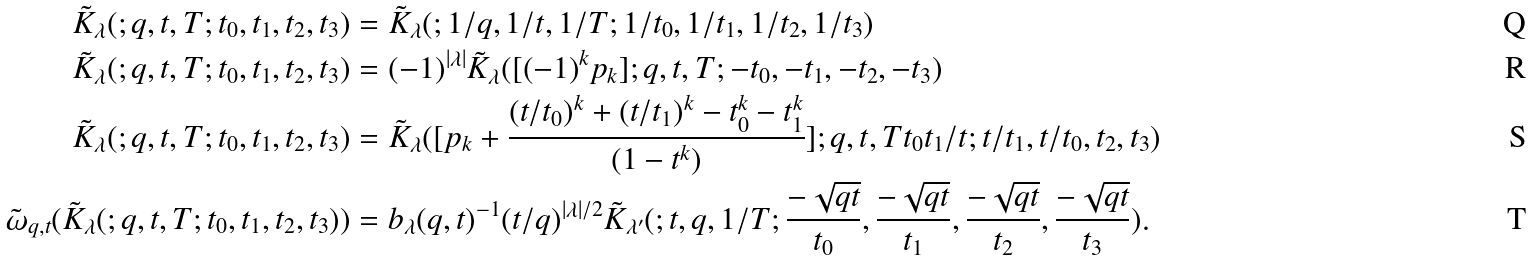<formula> <loc_0><loc_0><loc_500><loc_500>\tilde { K } _ { \lambda } ( ; q , t , T ; t _ { 0 } , t _ { 1 } , t _ { 2 } , t _ { 3 } ) & = \tilde { K } _ { \lambda } ( ; 1 / q , 1 / t , 1 / T ; 1 / t _ { 0 } , 1 / t _ { 1 } , 1 / t _ { 2 } , 1 / t _ { 3 } ) \\ \tilde { K } _ { \lambda } ( ; q , t , T ; t _ { 0 } , t _ { 1 } , t _ { 2 } , t _ { 3 } ) & = ( - 1 ) ^ { | \lambda | } \tilde { K } _ { \lambda } ( [ ( - 1 ) ^ { k } p _ { k } ] ; q , t , T ; - t _ { 0 } , - t _ { 1 } , - t _ { 2 } , - t _ { 3 } ) \\ \tilde { K } _ { \lambda } ( ; q , t , T ; t _ { 0 } , t _ { 1 } , t _ { 2 } , t _ { 3 } ) & = \tilde { K } _ { \lambda } ( [ p _ { k } + \frac { ( t / t _ { 0 } ) ^ { k } + ( t / t _ { 1 } ) ^ { k } - t _ { 0 } ^ { k } - t _ { 1 } ^ { k } } { ( 1 - t ^ { k } ) } ] ; q , t , T t _ { 0 } t _ { 1 } / t ; t / t _ { 1 } , t / t _ { 0 } , t _ { 2 } , t _ { 3 } ) \\ \tilde { \omega } _ { q , t } ( \tilde { K } _ { \lambda } ( ; q , t , T ; t _ { 0 } , t _ { 1 } , t _ { 2 } , t _ { 3 } ) ) & = b _ { \lambda } ( q , t ) ^ { - 1 } ( t / q ) ^ { | \lambda | / 2 } \tilde { K } _ { \lambda ^ { \prime } } ( ; t , q , 1 / T ; \frac { - \sqrt { q t } } { t _ { 0 } } , \frac { - \sqrt { q t } } { t _ { 1 } } , \frac { - \sqrt { q t } } { t _ { 2 } } , \frac { - \sqrt { q t } } { t _ { 3 } } ) .</formula> 